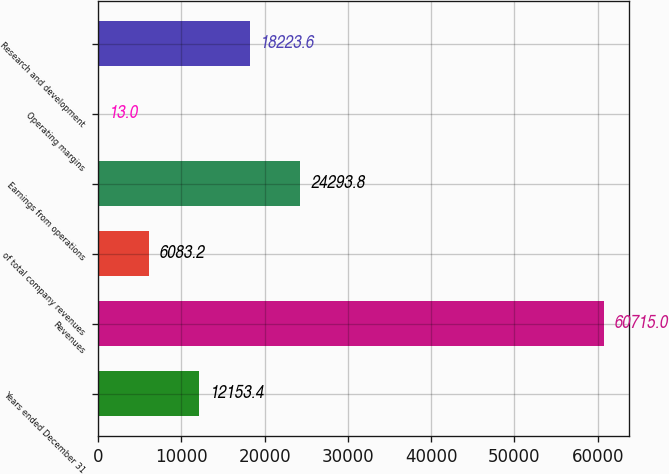Convert chart. <chart><loc_0><loc_0><loc_500><loc_500><bar_chart><fcel>Years ended December 31<fcel>Revenues<fcel>of total company revenues<fcel>Earnings from operations<fcel>Operating margins<fcel>Research and development<nl><fcel>12153.4<fcel>60715<fcel>6083.2<fcel>24293.8<fcel>13<fcel>18223.6<nl></chart> 